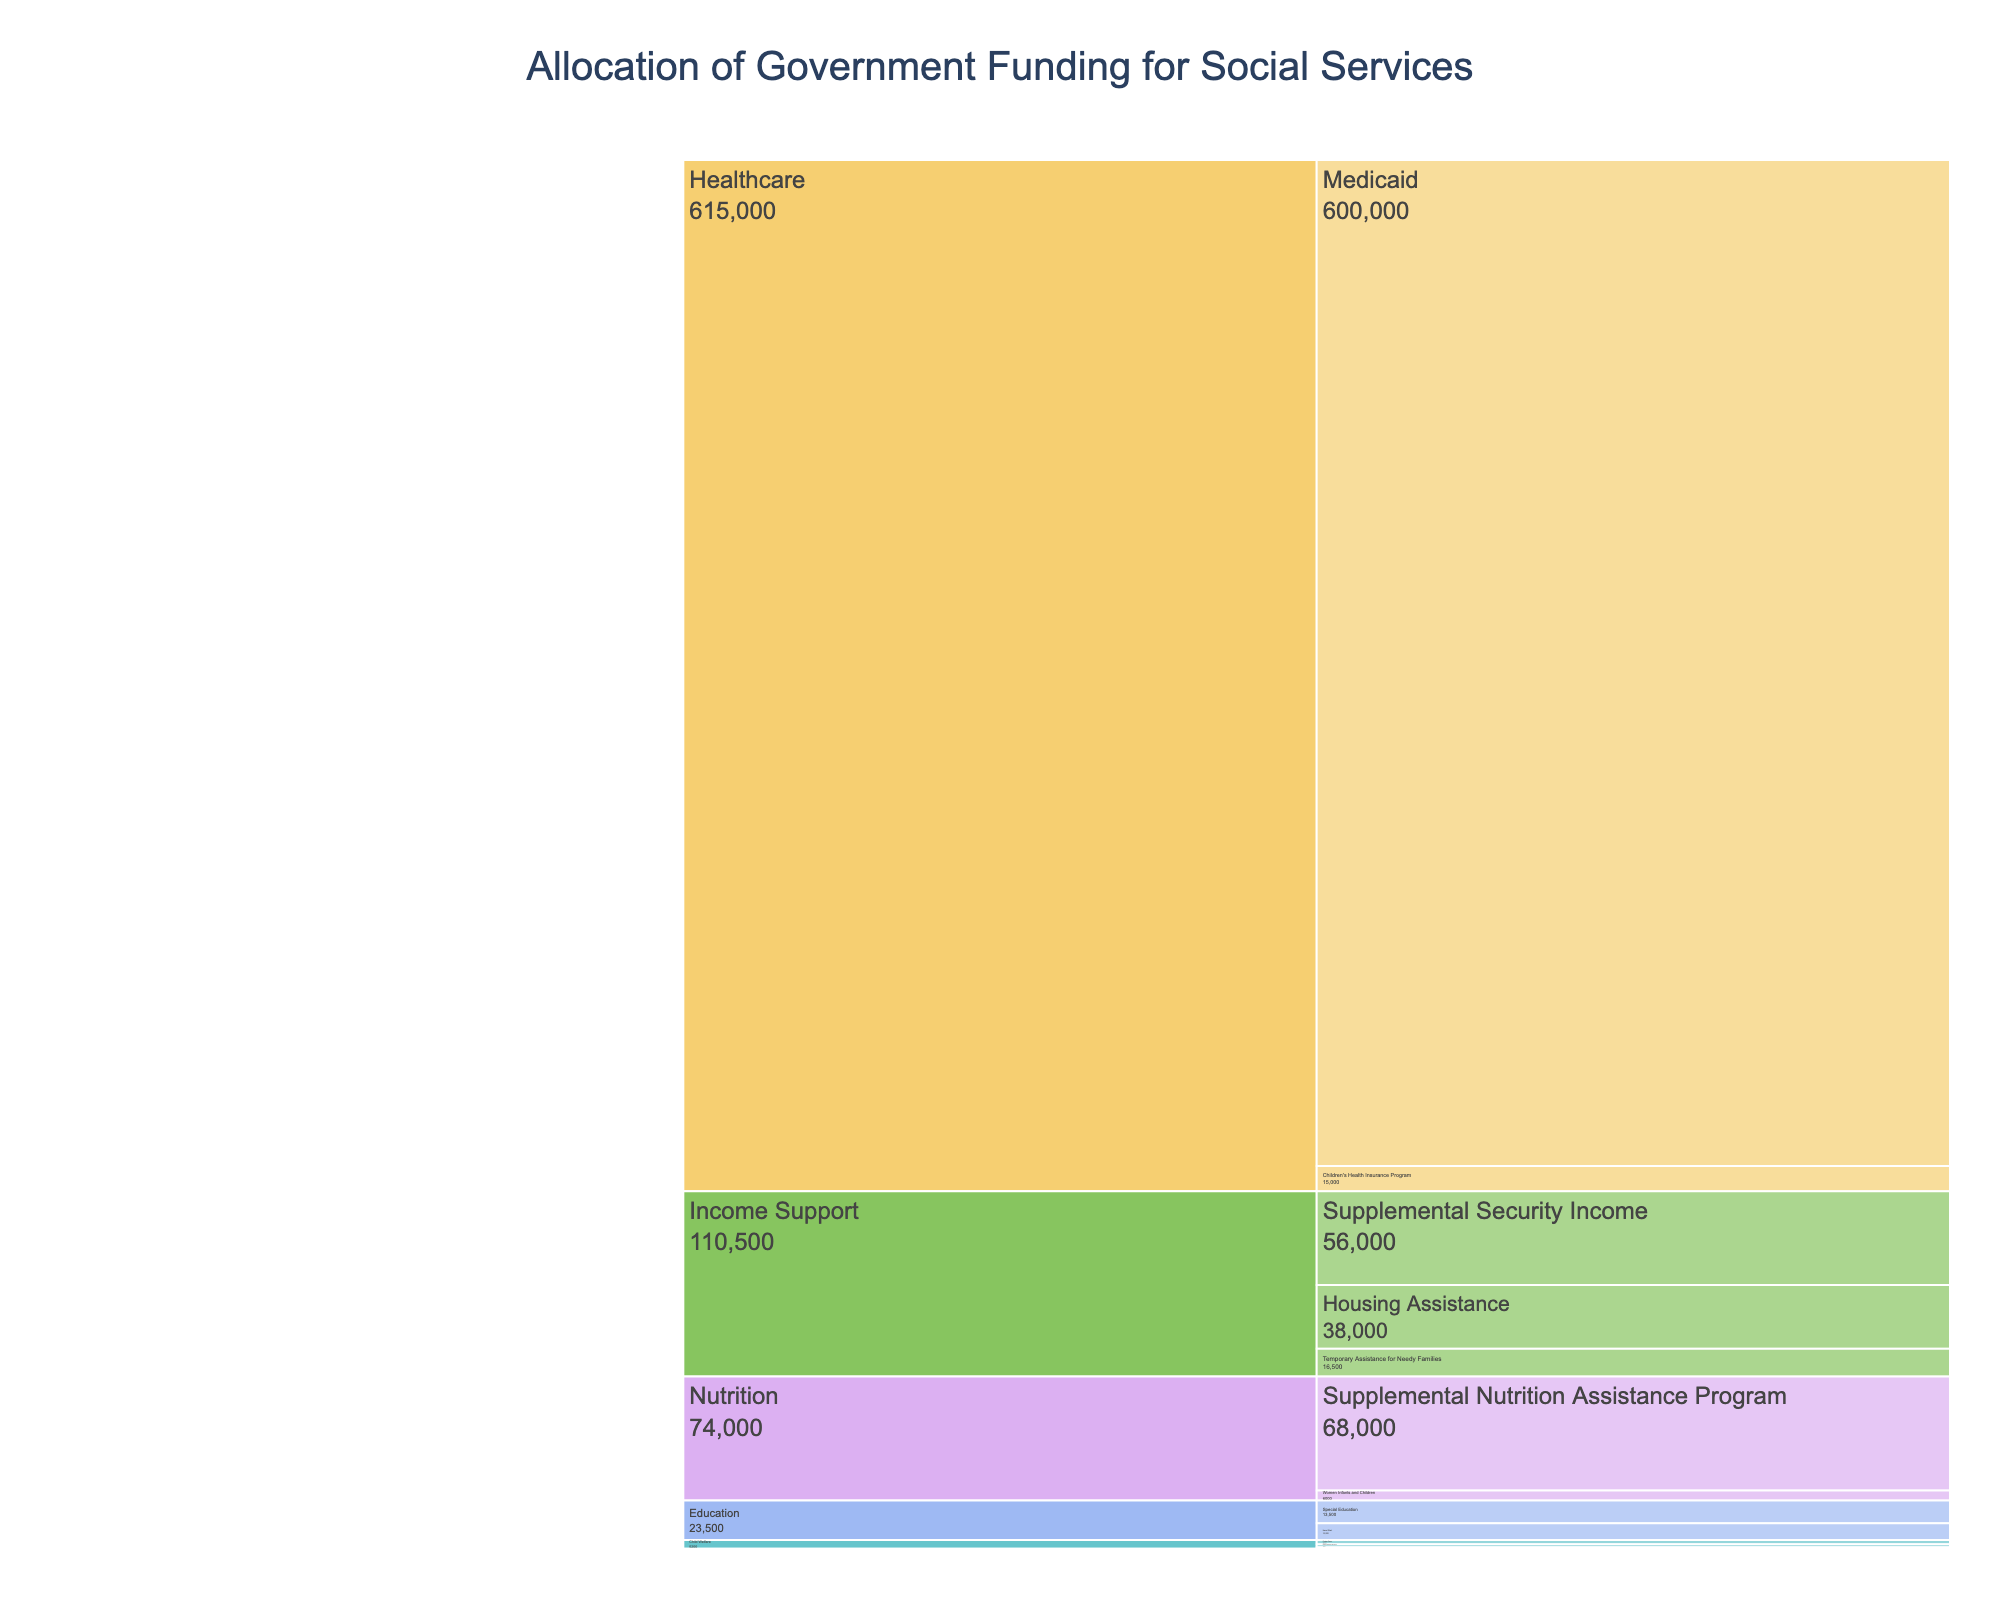What is the title of the figure? The title is displayed prominently at the top of the chart and provides the context of the data represented.
Answer: Allocation of Government Funding for Social Services What are the main categories in the chart? The main categories are indicated by the first level of the hierarchy in the icicle chart and represent broad areas of funding.
Answer: Child Welfare, Income Support, Legal Aid, Healthcare, Education, Nutrition Which subcategory within Income Support receives the highest funding? Within the Income Support category, each subcategory's funding is displayed; the highest number indicates the subcategory with the most funding.
Answer: Supplemental Security Income How much funding is allocated to Head Start in the Education category? Locate the Education category and its subcategories, then find the specific amount designated for Head Start.
Answer: $10,000 million What is the total funding for the Child Welfare category? Sum the funding amounts for all subcategories under Child Welfare: Foster Care, Child Protection Services, and Family Reunification.
Answer: $5,200 million Which category has the smallest allocation overall? Compare the total funding amounts of each main category to identify the smallest one.
Answer: Legal Aid How does the funding for Medicaid compare to Housing Assistance? Look at the funding amounts for both Medicaid and Housing Assistance and compare them numerically or visually.
Answer: Medicaid receives significantly more funding ($600,000 million vs. $38,000 million) Which subcategories receive funding in both the Child Welfare and Legal Aid categories? Identify subcategories belonging to both the Child Welfare and Legal Aid categories from the chart.
Answer: There are no common subcategories between Child Welfare and Legal Aid What is the combined funding for the Nutrition category? Add the funding for both subcategories within the Nutrition category: Supplemental Nutrition Assistance Program and Women Infants and Children.
Answer: $74,000 million Which subcategory within Legal Aid has the least funding? Find the subcategory within Legal Aid with the lowest funding amount.
Answer: Housing Rights 